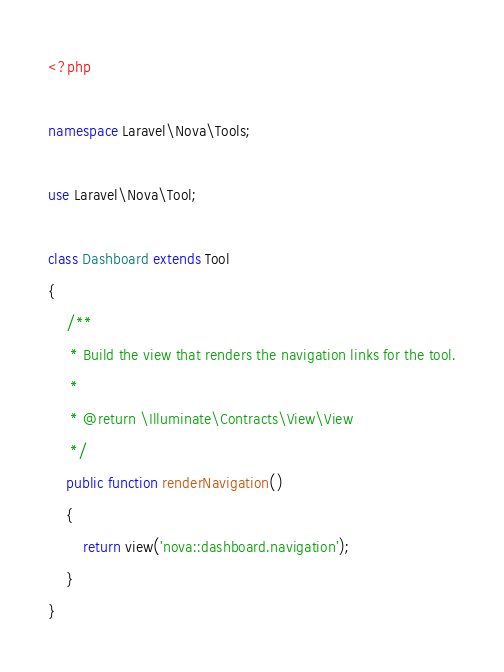Convert code to text. <code><loc_0><loc_0><loc_500><loc_500><_PHP_><?php

namespace Laravel\Nova\Tools;

use Laravel\Nova\Tool;

class Dashboard extends Tool
{
    /**
     * Build the view that renders the navigation links for the tool.
     *
     * @return \Illuminate\Contracts\View\View
     */
    public function renderNavigation()
    {
        return view('nova::dashboard.navigation');
    }
}
</code> 